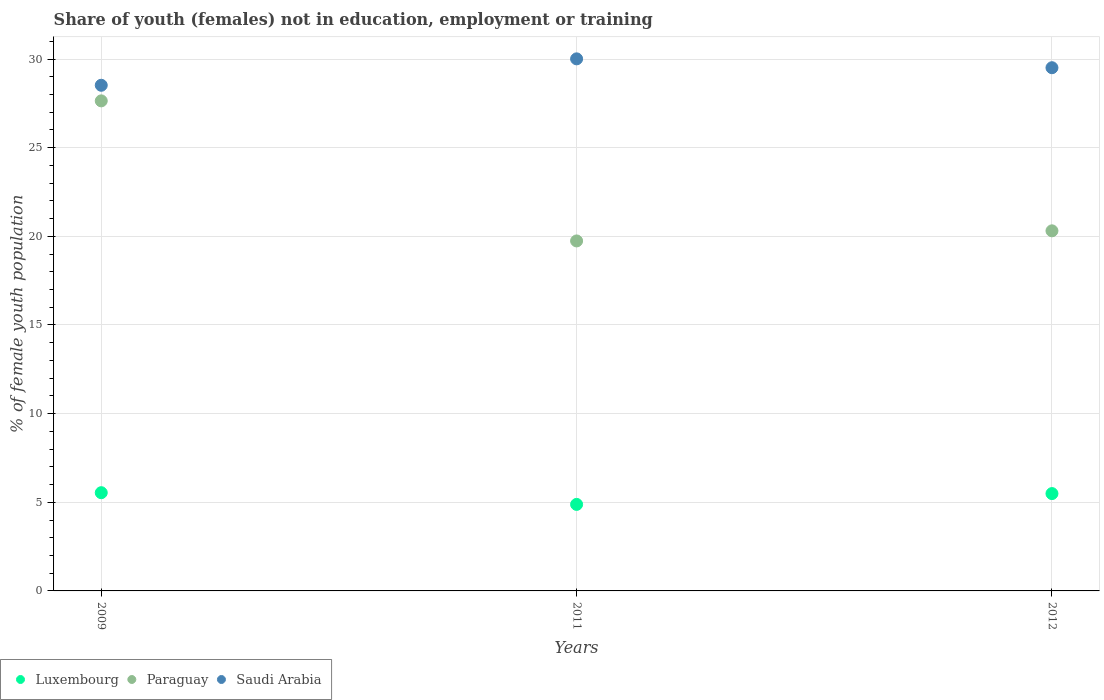Is the number of dotlines equal to the number of legend labels?
Make the answer very short. Yes. What is the percentage of unemployed female population in in Luxembourg in 2009?
Provide a short and direct response. 5.54. Across all years, what is the maximum percentage of unemployed female population in in Saudi Arabia?
Offer a terse response. 30.01. Across all years, what is the minimum percentage of unemployed female population in in Saudi Arabia?
Offer a very short reply. 28.52. In which year was the percentage of unemployed female population in in Luxembourg maximum?
Keep it short and to the point. 2009. In which year was the percentage of unemployed female population in in Luxembourg minimum?
Provide a succinct answer. 2011. What is the total percentage of unemployed female population in in Saudi Arabia in the graph?
Your response must be concise. 88.04. What is the difference between the percentage of unemployed female population in in Paraguay in 2011 and that in 2012?
Offer a very short reply. -0.57. What is the difference between the percentage of unemployed female population in in Luxembourg in 2011 and the percentage of unemployed female population in in Saudi Arabia in 2009?
Your response must be concise. -23.64. What is the average percentage of unemployed female population in in Paraguay per year?
Ensure brevity in your answer.  22.56. In the year 2009, what is the difference between the percentage of unemployed female population in in Paraguay and percentage of unemployed female population in in Luxembourg?
Offer a very short reply. 22.1. What is the ratio of the percentage of unemployed female population in in Saudi Arabia in 2009 to that in 2012?
Make the answer very short. 0.97. What is the difference between the highest and the second highest percentage of unemployed female population in in Saudi Arabia?
Your answer should be compact. 0.5. What is the difference between the highest and the lowest percentage of unemployed female population in in Saudi Arabia?
Offer a terse response. 1.49. In how many years, is the percentage of unemployed female population in in Saudi Arabia greater than the average percentage of unemployed female population in in Saudi Arabia taken over all years?
Provide a short and direct response. 2. Is the sum of the percentage of unemployed female population in in Luxembourg in 2009 and 2012 greater than the maximum percentage of unemployed female population in in Saudi Arabia across all years?
Your answer should be compact. No. Does the percentage of unemployed female population in in Saudi Arabia monotonically increase over the years?
Keep it short and to the point. No. How many years are there in the graph?
Your answer should be very brief. 3. What is the difference between two consecutive major ticks on the Y-axis?
Offer a very short reply. 5. Are the values on the major ticks of Y-axis written in scientific E-notation?
Provide a succinct answer. No. Where does the legend appear in the graph?
Make the answer very short. Bottom left. How are the legend labels stacked?
Keep it short and to the point. Horizontal. What is the title of the graph?
Keep it short and to the point. Share of youth (females) not in education, employment or training. What is the label or title of the Y-axis?
Offer a terse response. % of female youth population. What is the % of female youth population in Luxembourg in 2009?
Ensure brevity in your answer.  5.54. What is the % of female youth population of Paraguay in 2009?
Your answer should be compact. 27.64. What is the % of female youth population in Saudi Arabia in 2009?
Give a very brief answer. 28.52. What is the % of female youth population of Luxembourg in 2011?
Ensure brevity in your answer.  4.88. What is the % of female youth population in Paraguay in 2011?
Give a very brief answer. 19.74. What is the % of female youth population of Saudi Arabia in 2011?
Give a very brief answer. 30.01. What is the % of female youth population of Luxembourg in 2012?
Offer a very short reply. 5.49. What is the % of female youth population of Paraguay in 2012?
Offer a very short reply. 20.31. What is the % of female youth population in Saudi Arabia in 2012?
Make the answer very short. 29.51. Across all years, what is the maximum % of female youth population of Luxembourg?
Offer a very short reply. 5.54. Across all years, what is the maximum % of female youth population in Paraguay?
Your answer should be compact. 27.64. Across all years, what is the maximum % of female youth population of Saudi Arabia?
Your response must be concise. 30.01. Across all years, what is the minimum % of female youth population of Luxembourg?
Provide a succinct answer. 4.88. Across all years, what is the minimum % of female youth population in Paraguay?
Make the answer very short. 19.74. Across all years, what is the minimum % of female youth population in Saudi Arabia?
Your answer should be very brief. 28.52. What is the total % of female youth population in Luxembourg in the graph?
Ensure brevity in your answer.  15.91. What is the total % of female youth population of Paraguay in the graph?
Make the answer very short. 67.69. What is the total % of female youth population in Saudi Arabia in the graph?
Make the answer very short. 88.04. What is the difference between the % of female youth population in Luxembourg in 2009 and that in 2011?
Your answer should be compact. 0.66. What is the difference between the % of female youth population in Saudi Arabia in 2009 and that in 2011?
Your response must be concise. -1.49. What is the difference between the % of female youth population of Paraguay in 2009 and that in 2012?
Offer a very short reply. 7.33. What is the difference between the % of female youth population of Saudi Arabia in 2009 and that in 2012?
Your response must be concise. -0.99. What is the difference between the % of female youth population of Luxembourg in 2011 and that in 2012?
Give a very brief answer. -0.61. What is the difference between the % of female youth population of Paraguay in 2011 and that in 2012?
Keep it short and to the point. -0.57. What is the difference between the % of female youth population in Luxembourg in 2009 and the % of female youth population in Saudi Arabia in 2011?
Offer a very short reply. -24.47. What is the difference between the % of female youth population in Paraguay in 2009 and the % of female youth population in Saudi Arabia in 2011?
Your answer should be very brief. -2.37. What is the difference between the % of female youth population in Luxembourg in 2009 and the % of female youth population in Paraguay in 2012?
Provide a short and direct response. -14.77. What is the difference between the % of female youth population in Luxembourg in 2009 and the % of female youth population in Saudi Arabia in 2012?
Provide a short and direct response. -23.97. What is the difference between the % of female youth population of Paraguay in 2009 and the % of female youth population of Saudi Arabia in 2012?
Keep it short and to the point. -1.87. What is the difference between the % of female youth population in Luxembourg in 2011 and the % of female youth population in Paraguay in 2012?
Provide a succinct answer. -15.43. What is the difference between the % of female youth population of Luxembourg in 2011 and the % of female youth population of Saudi Arabia in 2012?
Offer a terse response. -24.63. What is the difference between the % of female youth population in Paraguay in 2011 and the % of female youth population in Saudi Arabia in 2012?
Provide a succinct answer. -9.77. What is the average % of female youth population of Luxembourg per year?
Keep it short and to the point. 5.3. What is the average % of female youth population in Paraguay per year?
Your answer should be very brief. 22.56. What is the average % of female youth population of Saudi Arabia per year?
Keep it short and to the point. 29.35. In the year 2009, what is the difference between the % of female youth population in Luxembourg and % of female youth population in Paraguay?
Your answer should be compact. -22.1. In the year 2009, what is the difference between the % of female youth population of Luxembourg and % of female youth population of Saudi Arabia?
Provide a succinct answer. -22.98. In the year 2009, what is the difference between the % of female youth population of Paraguay and % of female youth population of Saudi Arabia?
Offer a terse response. -0.88. In the year 2011, what is the difference between the % of female youth population in Luxembourg and % of female youth population in Paraguay?
Your answer should be compact. -14.86. In the year 2011, what is the difference between the % of female youth population of Luxembourg and % of female youth population of Saudi Arabia?
Provide a succinct answer. -25.13. In the year 2011, what is the difference between the % of female youth population of Paraguay and % of female youth population of Saudi Arabia?
Your response must be concise. -10.27. In the year 2012, what is the difference between the % of female youth population of Luxembourg and % of female youth population of Paraguay?
Give a very brief answer. -14.82. In the year 2012, what is the difference between the % of female youth population of Luxembourg and % of female youth population of Saudi Arabia?
Your response must be concise. -24.02. What is the ratio of the % of female youth population of Luxembourg in 2009 to that in 2011?
Provide a succinct answer. 1.14. What is the ratio of the % of female youth population in Paraguay in 2009 to that in 2011?
Keep it short and to the point. 1.4. What is the ratio of the % of female youth population in Saudi Arabia in 2009 to that in 2011?
Provide a short and direct response. 0.95. What is the ratio of the % of female youth population in Luxembourg in 2009 to that in 2012?
Give a very brief answer. 1.01. What is the ratio of the % of female youth population of Paraguay in 2009 to that in 2012?
Provide a succinct answer. 1.36. What is the ratio of the % of female youth population in Saudi Arabia in 2009 to that in 2012?
Offer a very short reply. 0.97. What is the ratio of the % of female youth population of Luxembourg in 2011 to that in 2012?
Provide a succinct answer. 0.89. What is the ratio of the % of female youth population of Paraguay in 2011 to that in 2012?
Provide a short and direct response. 0.97. What is the ratio of the % of female youth population of Saudi Arabia in 2011 to that in 2012?
Keep it short and to the point. 1.02. What is the difference between the highest and the second highest % of female youth population of Paraguay?
Give a very brief answer. 7.33. What is the difference between the highest and the lowest % of female youth population of Luxembourg?
Make the answer very short. 0.66. What is the difference between the highest and the lowest % of female youth population in Saudi Arabia?
Keep it short and to the point. 1.49. 